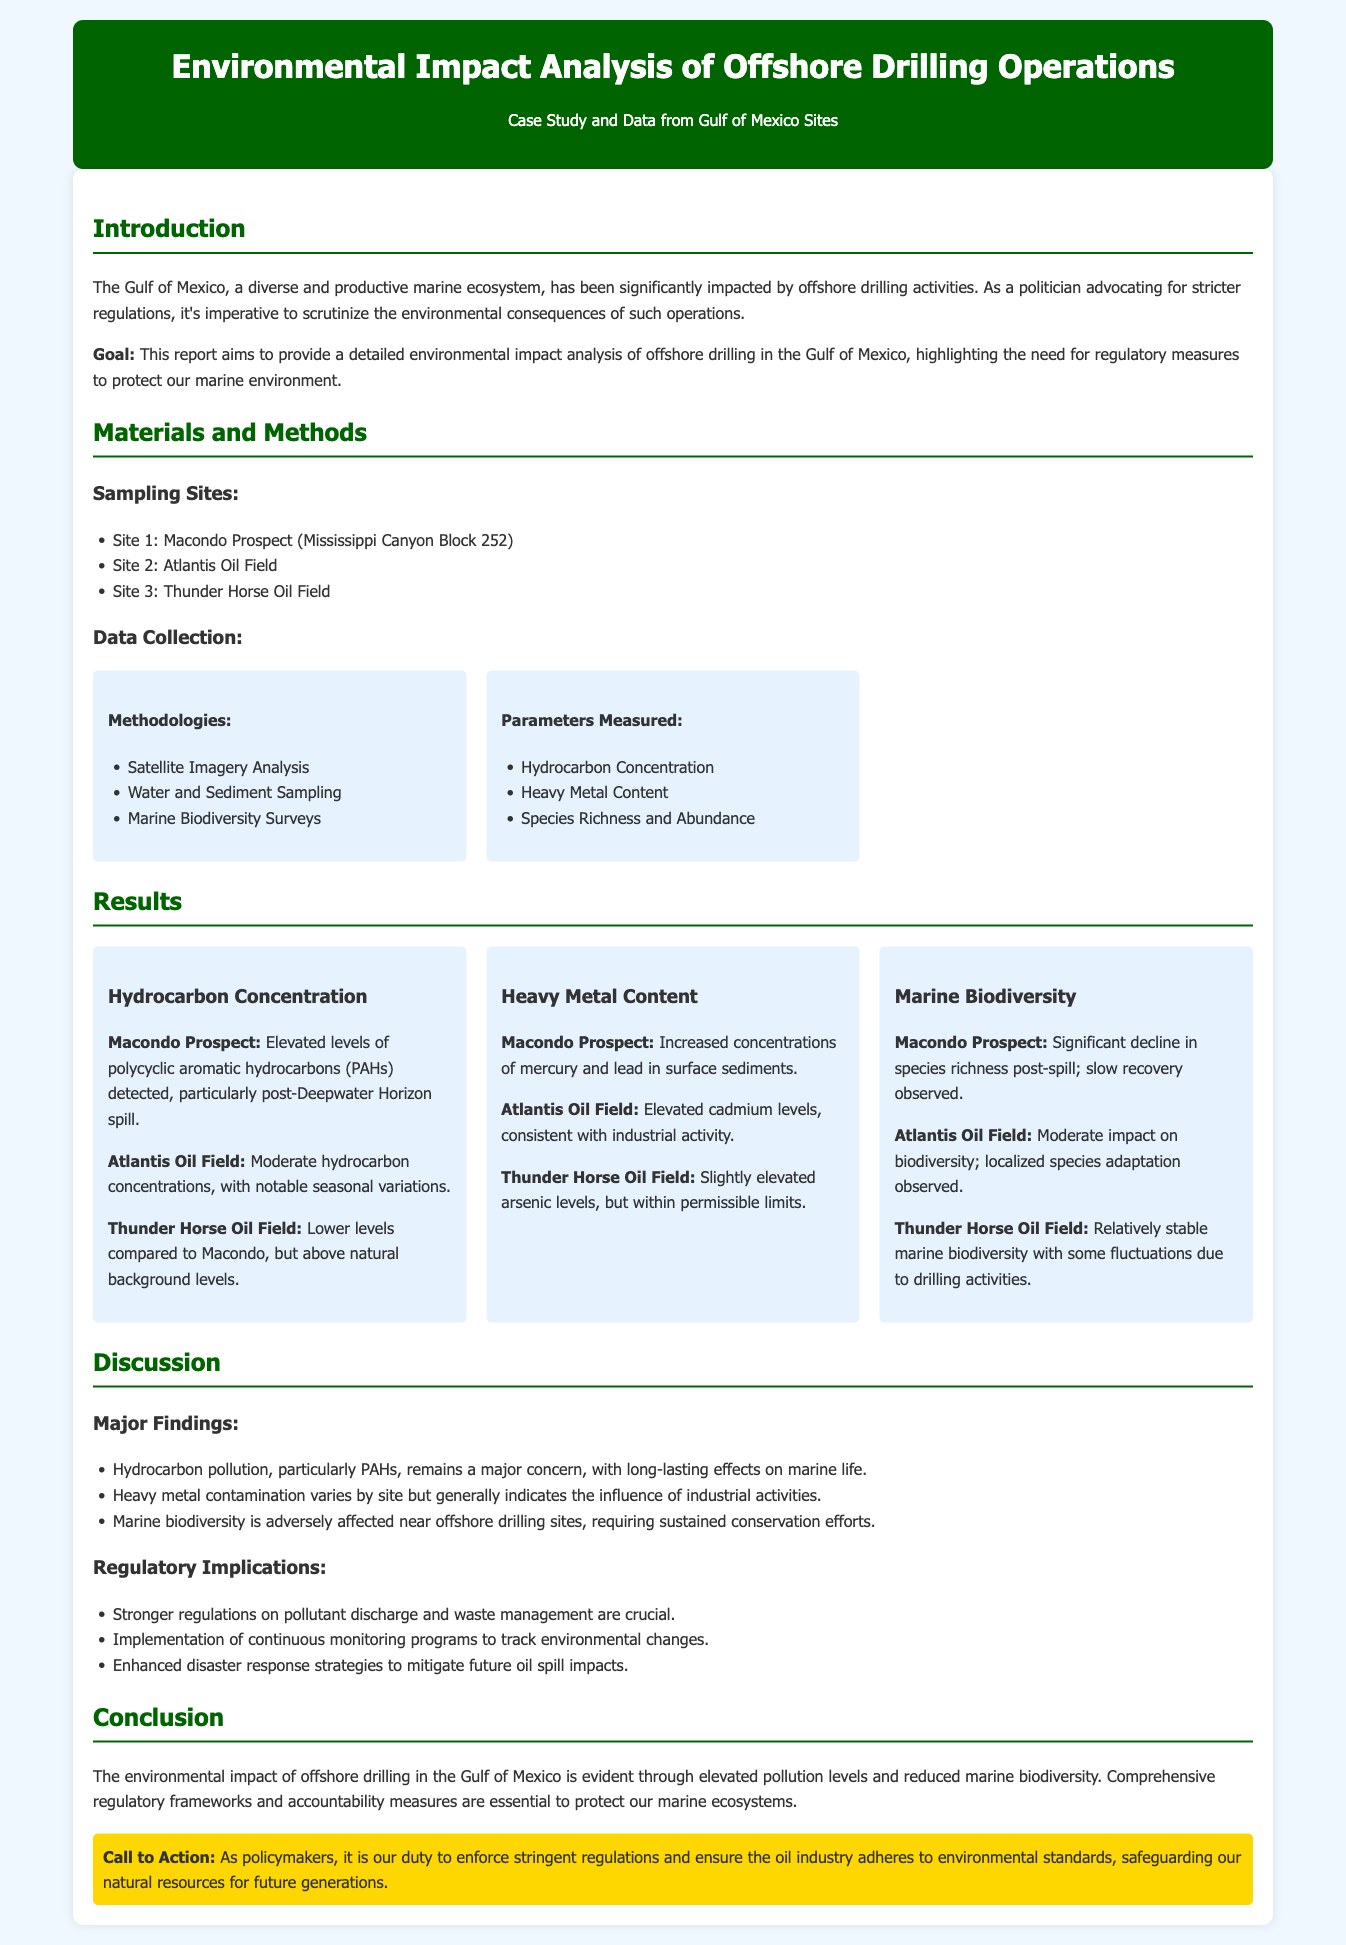What is the main focus of the report? The report aims to provide an analysis of the environmental impact of offshore drilling in the Gulf of Mexico to highlight the need for regulations.
Answer: Environmental impact analysis How many sampling sites were studied? The document lists three sites for sampling in the Gulf of Mexico.
Answer: Three What is the primary methodology used for data collection? The methodologies include satellite imagery analysis, water and sediment sampling, and marine biodiversity surveys.
Answer: Satellite Imagery Analysis Which site had elevated levels of polycyclic aromatic hydrocarbons detected? The report states that the Macondo Prospect showed elevated levels of PAHs.
Answer: Macondo Prospect What has happened to species richness at the Macondo Prospect post-spill? The report indicates that there has been a significant decline in species richness at that site.
Answer: Significant decline What heavy metal content was increased in surface sediments at the Macondo Prospect? The report mentions increased concentrations of mercury and lead.
Answer: Mercury and lead What regulatory implication does the report suggest regarding pollutant discharge? The report stresses the need for stronger regulations on pollutant discharge and waste management.
Answer: Stronger regulations What type of ecological impact should be sustained according to the findings? The findings emphasize the need for sustained conservation efforts for marine biodiversity.
Answer: Conservation efforts 